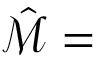Convert formula to latex. <formula><loc_0><loc_0><loc_500><loc_500>\hat { \mathcal { M } } =</formula> 